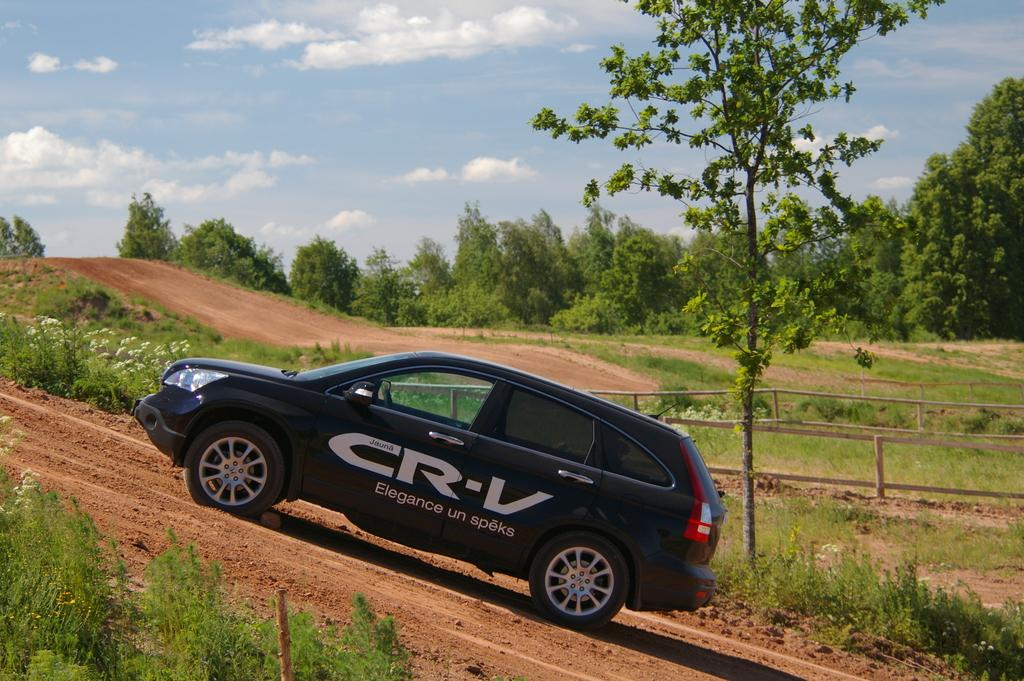What color is the car in the image? The car in the image is black. What type of vegetation can be seen in the image? There are trees and plants in the image. How would you describe the sky in the image? The sky in the image is blue and cloudy. What type of milk is being served in the image? There is no milk present in the image. Is there a team playing a game in the image? There is no team or game being played in the image. 